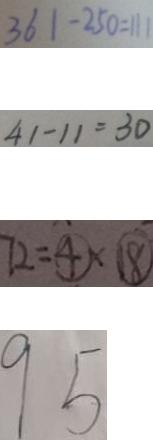Convert formula to latex. <formula><loc_0><loc_0><loc_500><loc_500>3 6 1 - 2 5 0 = 1 1 1 
 4 1 - 1 1 = 3 0 
 7 2 = \textcircled { 4 } \times \textcircled { 1 8 } 
 9 5</formula> 